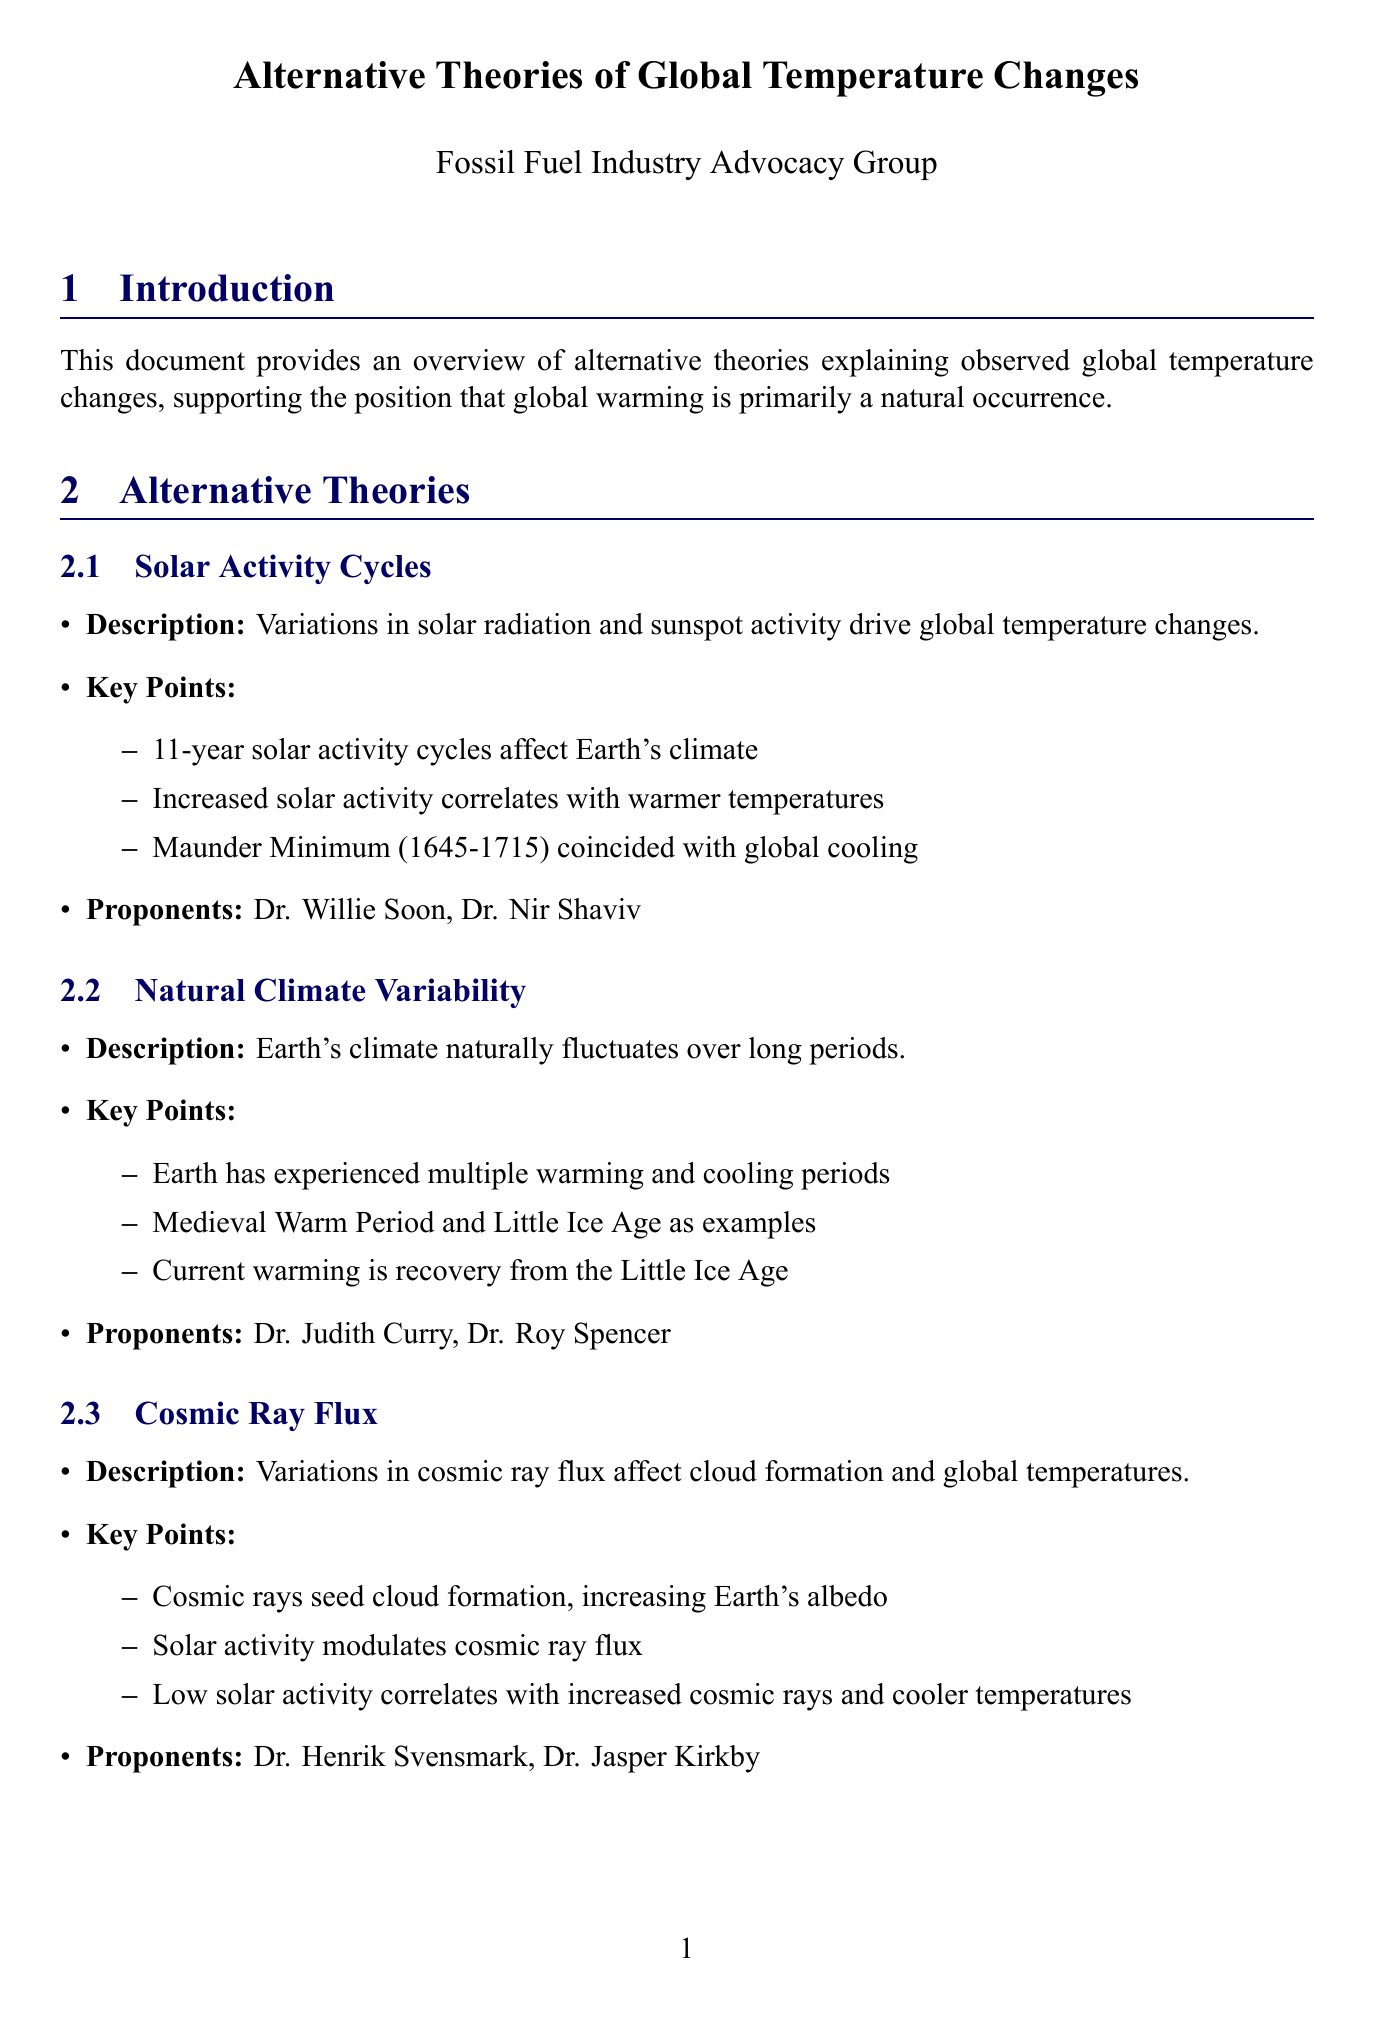What are the two examples of natural climate variations mentioned? The two examples are the Medieval Warm Period and the Little Ice Age, which illustrate historical climate fluctuations.
Answer: Medieval Warm Period, Little Ice Age Who is a proponent of the Solar Activity Cycles theory? This question asks for an individual associated with the Solar Activity Cycles theory as mentioned in the document.
Answer: Dr. Willie Soon What is the recommendation for Energy Policy? This question references the suggested approach to energy policy to ensure economic stability and security as stated in the document.
Answer: Maintain a diverse energy portfolio, including fossil fuels What is the main concept of the Urban Heat Island Effect? The question pertains to the description of how urbanization contributes to observed temperature changes according to the document.
Answer: Urbanization and land-use changes cause observed warming Which theory correlates low solar activity with cooler temperatures? The question requires identifying the theory that explains the relationship between cosmic ray flux and solar activity impacting global temperatures.
Answer: Cosmic Ray Flux How many theories are discussed in this document? This question asks for a count of the alternative theories detailing global temperature changes provided within the document.
Answer: Five 